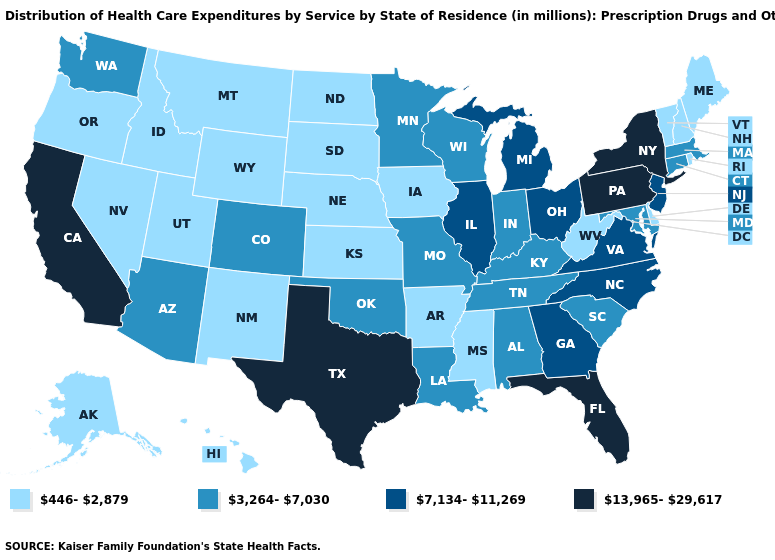Which states have the lowest value in the MidWest?
Quick response, please. Iowa, Kansas, Nebraska, North Dakota, South Dakota. Which states have the lowest value in the USA?
Be succinct. Alaska, Arkansas, Delaware, Hawaii, Idaho, Iowa, Kansas, Maine, Mississippi, Montana, Nebraska, Nevada, New Hampshire, New Mexico, North Dakota, Oregon, Rhode Island, South Dakota, Utah, Vermont, West Virginia, Wyoming. Does the map have missing data?
Give a very brief answer. No. Name the states that have a value in the range 13,965-29,617?
Write a very short answer. California, Florida, New York, Pennsylvania, Texas. Which states have the lowest value in the USA?
Answer briefly. Alaska, Arkansas, Delaware, Hawaii, Idaho, Iowa, Kansas, Maine, Mississippi, Montana, Nebraska, Nevada, New Hampshire, New Mexico, North Dakota, Oregon, Rhode Island, South Dakota, Utah, Vermont, West Virginia, Wyoming. Which states have the highest value in the USA?
Keep it brief. California, Florida, New York, Pennsylvania, Texas. Name the states that have a value in the range 13,965-29,617?
Concise answer only. California, Florida, New York, Pennsylvania, Texas. Among the states that border Montana , which have the lowest value?
Keep it brief. Idaho, North Dakota, South Dakota, Wyoming. Among the states that border Vermont , which have the lowest value?
Quick response, please. New Hampshire. What is the value of Michigan?
Write a very short answer. 7,134-11,269. What is the value of California?
Be succinct. 13,965-29,617. Name the states that have a value in the range 13,965-29,617?
Be succinct. California, Florida, New York, Pennsylvania, Texas. Name the states that have a value in the range 13,965-29,617?
Answer briefly. California, Florida, New York, Pennsylvania, Texas. Does New York have the highest value in the Northeast?
Concise answer only. Yes. 